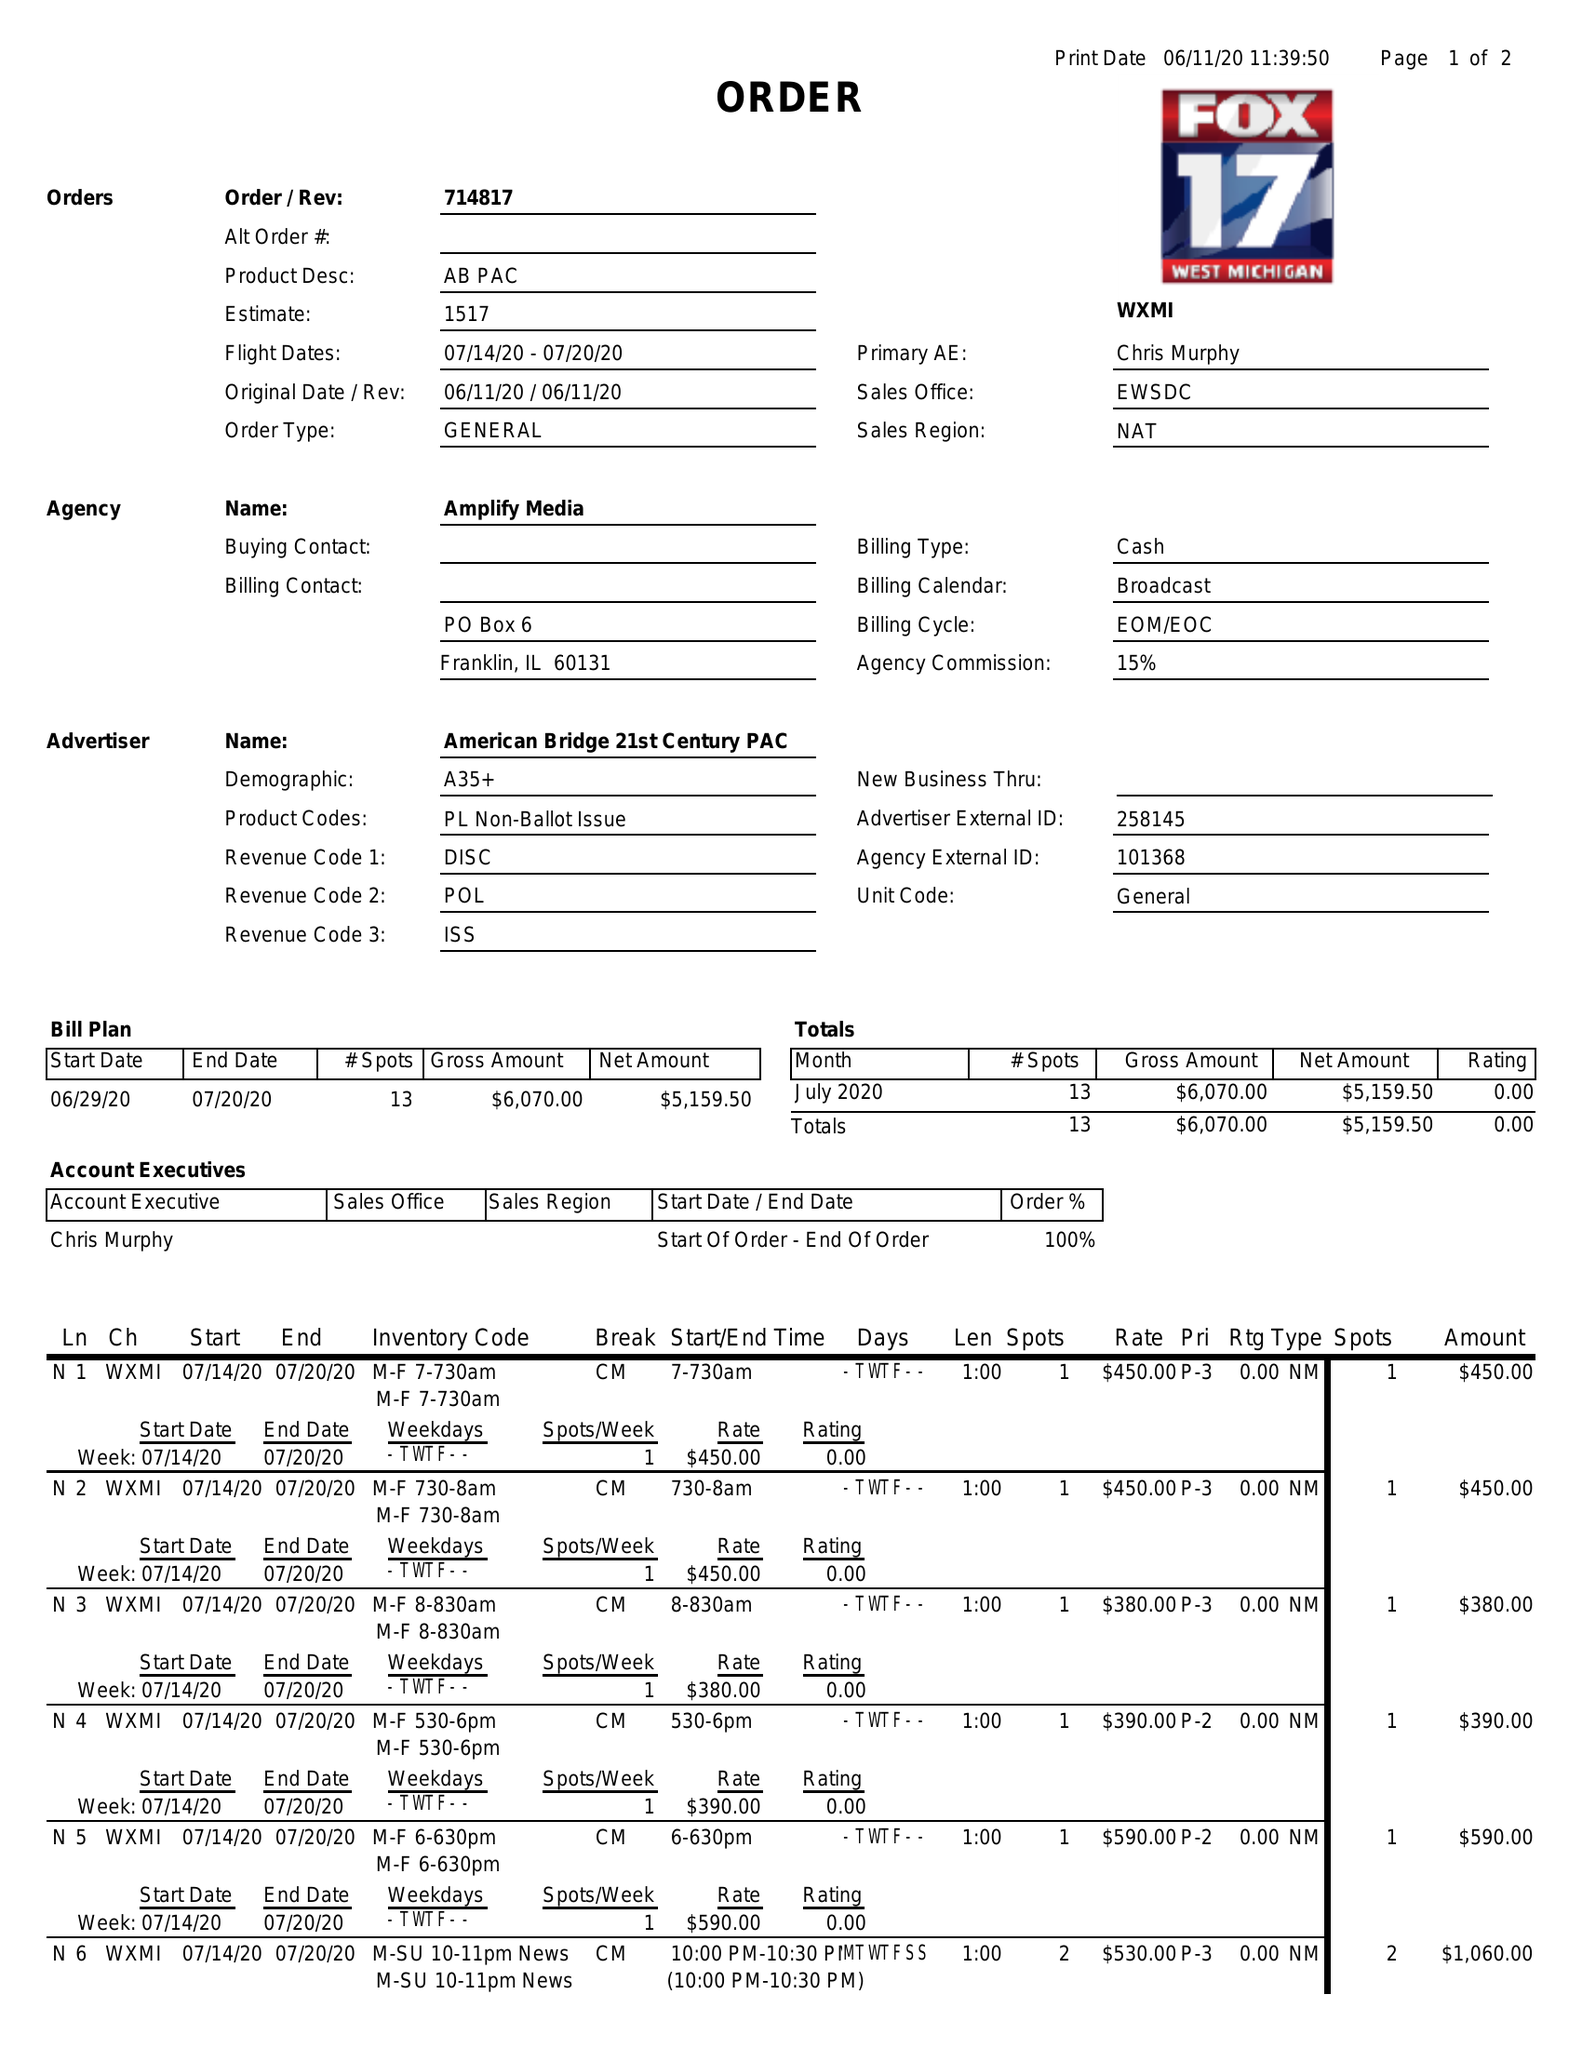What is the value for the advertiser?
Answer the question using a single word or phrase. AMERICAN BRIDGE 21ST CENTURY PAC 